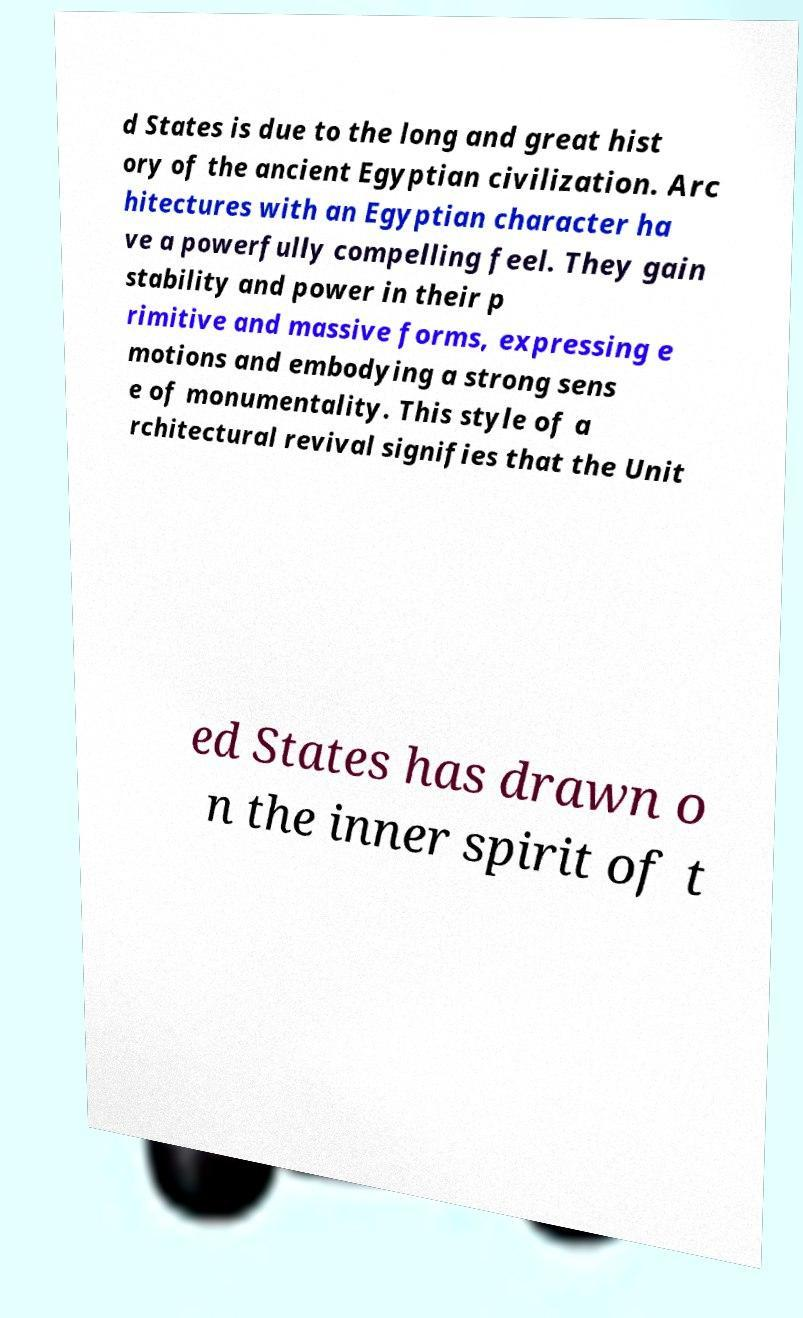What messages or text are displayed in this image? I need them in a readable, typed format. d States is due to the long and great hist ory of the ancient Egyptian civilization. Arc hitectures with an Egyptian character ha ve a powerfully compelling feel. They gain stability and power in their p rimitive and massive forms, expressing e motions and embodying a strong sens e of monumentality. This style of a rchitectural revival signifies that the Unit ed States has drawn o n the inner spirit of t 